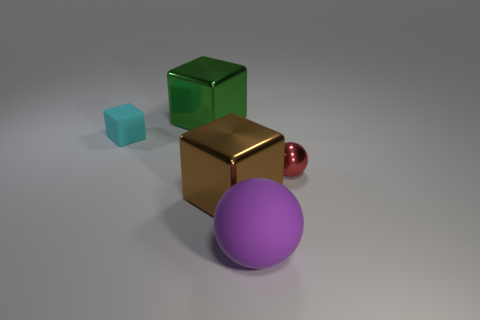What could be the purpose of arranging these objects in this manner? The arrangement of these objects could serve several purposes. It may be a part of a visual composition or an artistic showcase, emphasizing color contrasts and geometry. Additionally, it could be a setup for a photography project to demonstrate depth of field or a 3D rendering that highlights texture and lighting effects. 